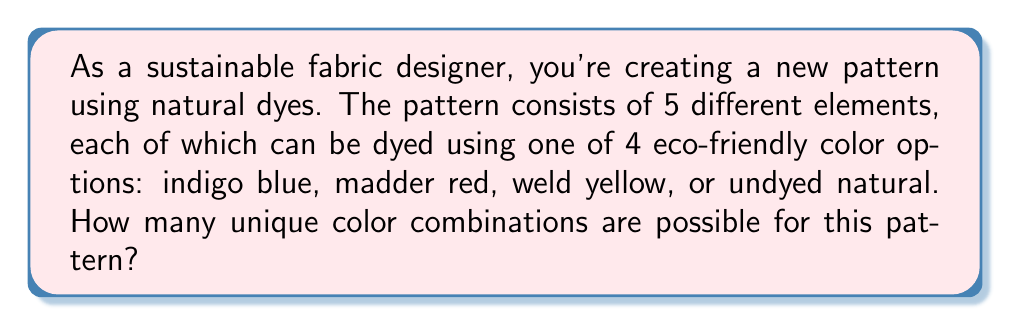Teach me how to tackle this problem. To solve this problem, we'll use the multiplication principle of counting. Here's the step-by-step solution:

1. Identify the number of choices for each element:
   Each of the 5 elements can be one of 4 colors.

2. Apply the multiplication principle:
   Since each choice is independent, we multiply the number of options for each element:

   $$\text{Total combinations} = 4 \times 4 \times 4 \times 4 \times 4$$

3. Simplify the expression:
   $$\text{Total combinations} = 4^5$$

4. Calculate the result:
   $$4^5 = 4 \times 4 \times 4 \times 4 \times 4 = 1024$$

Therefore, there are 1024 unique color combinations possible for this pattern.
Answer: 1024 